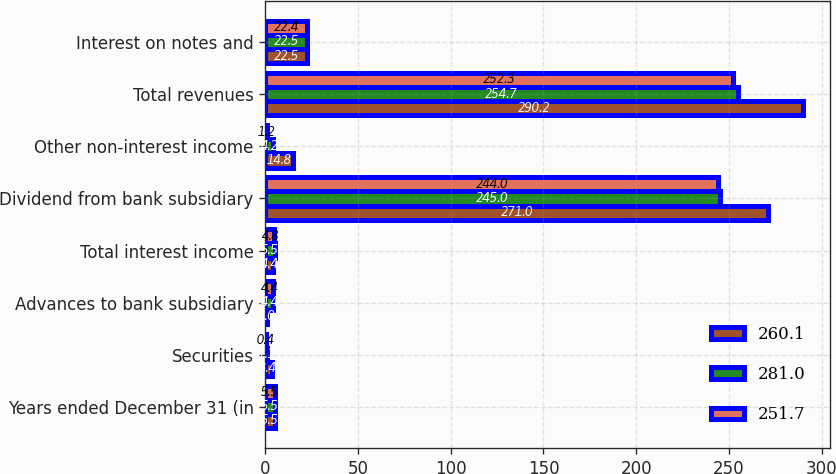Convert chart. <chart><loc_0><loc_0><loc_500><loc_500><stacked_bar_chart><ecel><fcel>Years ended December 31 (in<fcel>Securities<fcel>Advances to bank subsidiary<fcel>Total interest income<fcel>Dividend from bank subsidiary<fcel>Other non-interest income<fcel>Total revenues<fcel>Interest on notes and<nl><fcel>260.1<fcel>5.5<fcel>3.4<fcel>1<fcel>4.4<fcel>271<fcel>14.8<fcel>290.2<fcel>22.5<nl><fcel>281<fcel>5.5<fcel>1.1<fcel>4.4<fcel>5.5<fcel>245<fcel>4.2<fcel>254.7<fcel>22.5<nl><fcel>251.7<fcel>5.5<fcel>0.4<fcel>4.4<fcel>4.8<fcel>244<fcel>1.2<fcel>252.3<fcel>22.4<nl></chart> 